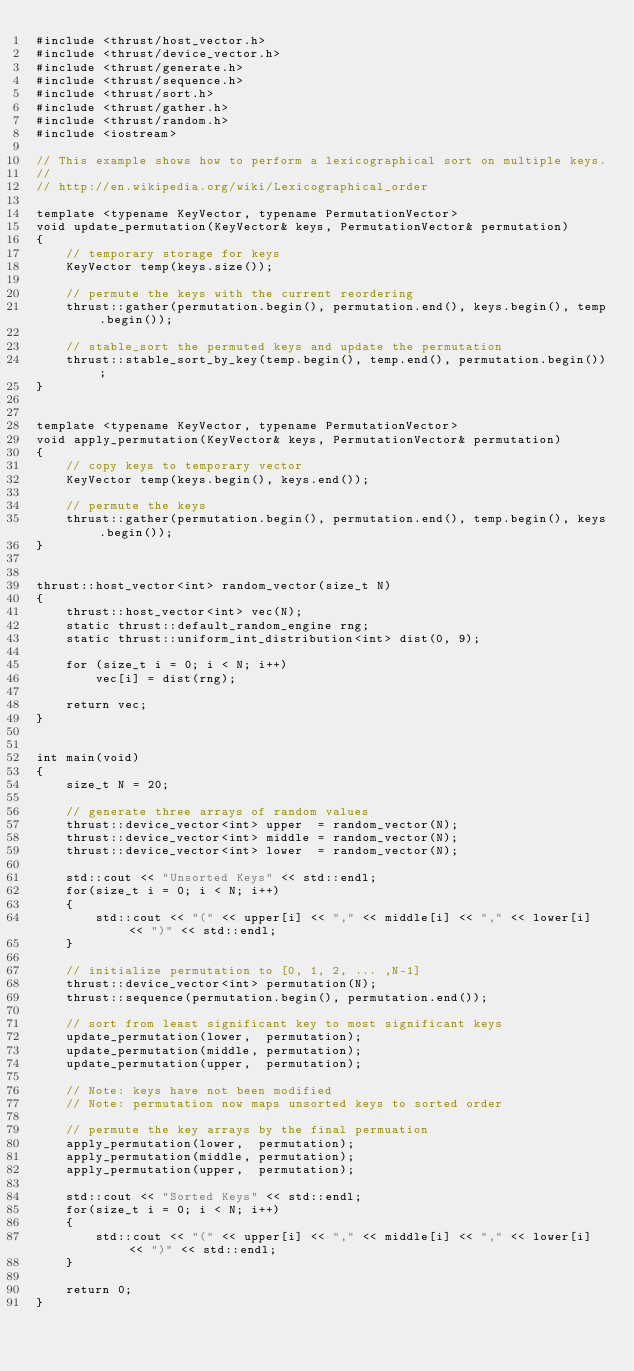<code> <loc_0><loc_0><loc_500><loc_500><_Cuda_>#include <thrust/host_vector.h>
#include <thrust/device_vector.h>
#include <thrust/generate.h>
#include <thrust/sequence.h>
#include <thrust/sort.h>
#include <thrust/gather.h>
#include <thrust/random.h>
#include <iostream>

// This example shows how to perform a lexicographical sort on multiple keys.
//
// http://en.wikipedia.org/wiki/Lexicographical_order

template <typename KeyVector, typename PermutationVector>
void update_permutation(KeyVector& keys, PermutationVector& permutation)
{
    // temporary storage for keys
    KeyVector temp(keys.size());

    // permute the keys with the current reordering
    thrust::gather(permutation.begin(), permutation.end(), keys.begin(), temp.begin());

    // stable_sort the permuted keys and update the permutation
    thrust::stable_sort_by_key(temp.begin(), temp.end(), permutation.begin());
}


template <typename KeyVector, typename PermutationVector>
void apply_permutation(KeyVector& keys, PermutationVector& permutation)
{
    // copy keys to temporary vector
    KeyVector temp(keys.begin(), keys.end());

    // permute the keys
    thrust::gather(permutation.begin(), permutation.end(), temp.begin(), keys.begin());
}


thrust::host_vector<int> random_vector(size_t N)
{
    thrust::host_vector<int> vec(N);
    static thrust::default_random_engine rng;
    static thrust::uniform_int_distribution<int> dist(0, 9);

    for (size_t i = 0; i < N; i++)
        vec[i] = dist(rng);

    return vec;
}


int main(void)
{
    size_t N = 20;

    // generate three arrays of random values
    thrust::device_vector<int> upper  = random_vector(N);
    thrust::device_vector<int> middle = random_vector(N);
    thrust::device_vector<int> lower  = random_vector(N);
    
    std::cout << "Unsorted Keys" << std::endl;
    for(size_t i = 0; i < N; i++)
    {
        std::cout << "(" << upper[i] << "," << middle[i] << "," << lower[i] << ")" << std::endl;
    }

    // initialize permutation to [0, 1, 2, ... ,N-1]
    thrust::device_vector<int> permutation(N);
    thrust::sequence(permutation.begin(), permutation.end());

    // sort from least significant key to most significant keys
    update_permutation(lower,  permutation);
    update_permutation(middle, permutation);
    update_permutation(upper,  permutation);

    // Note: keys have not been modified
    // Note: permutation now maps unsorted keys to sorted order
  
    // permute the key arrays by the final permuation
    apply_permutation(lower,  permutation);
    apply_permutation(middle, permutation);
    apply_permutation(upper,  permutation);

    std::cout << "Sorted Keys" << std::endl;
    for(size_t i = 0; i < N; i++)
    {
        std::cout << "(" << upper[i] << "," << middle[i] << "," << lower[i] << ")" << std::endl;
    }

    return 0;
}

</code> 